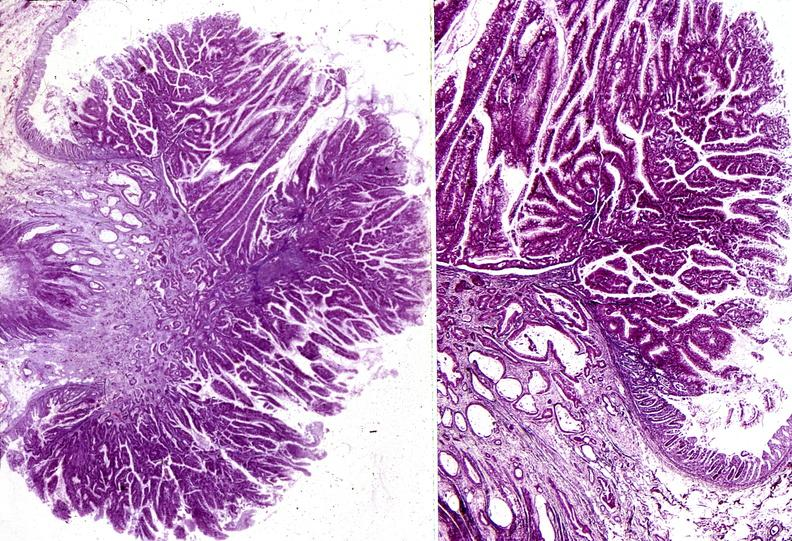does abdomen show colon, villous polyp and adenocarcinoma?
Answer the question using a single word or phrase. No 